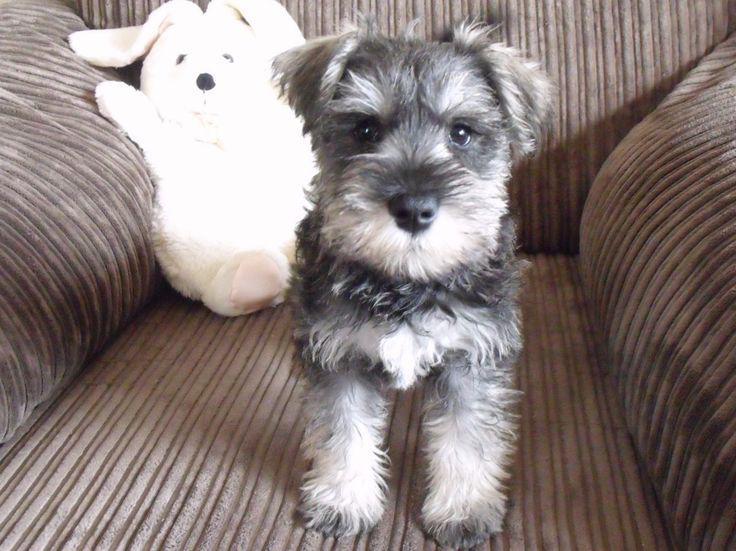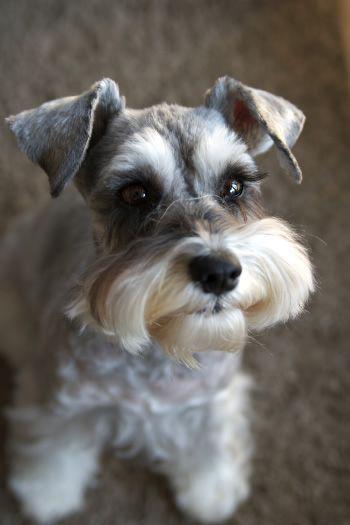The first image is the image on the left, the second image is the image on the right. For the images shown, is this caption "One image shows a schnauzer standing and facing toward the right." true? Answer yes or no. No. 